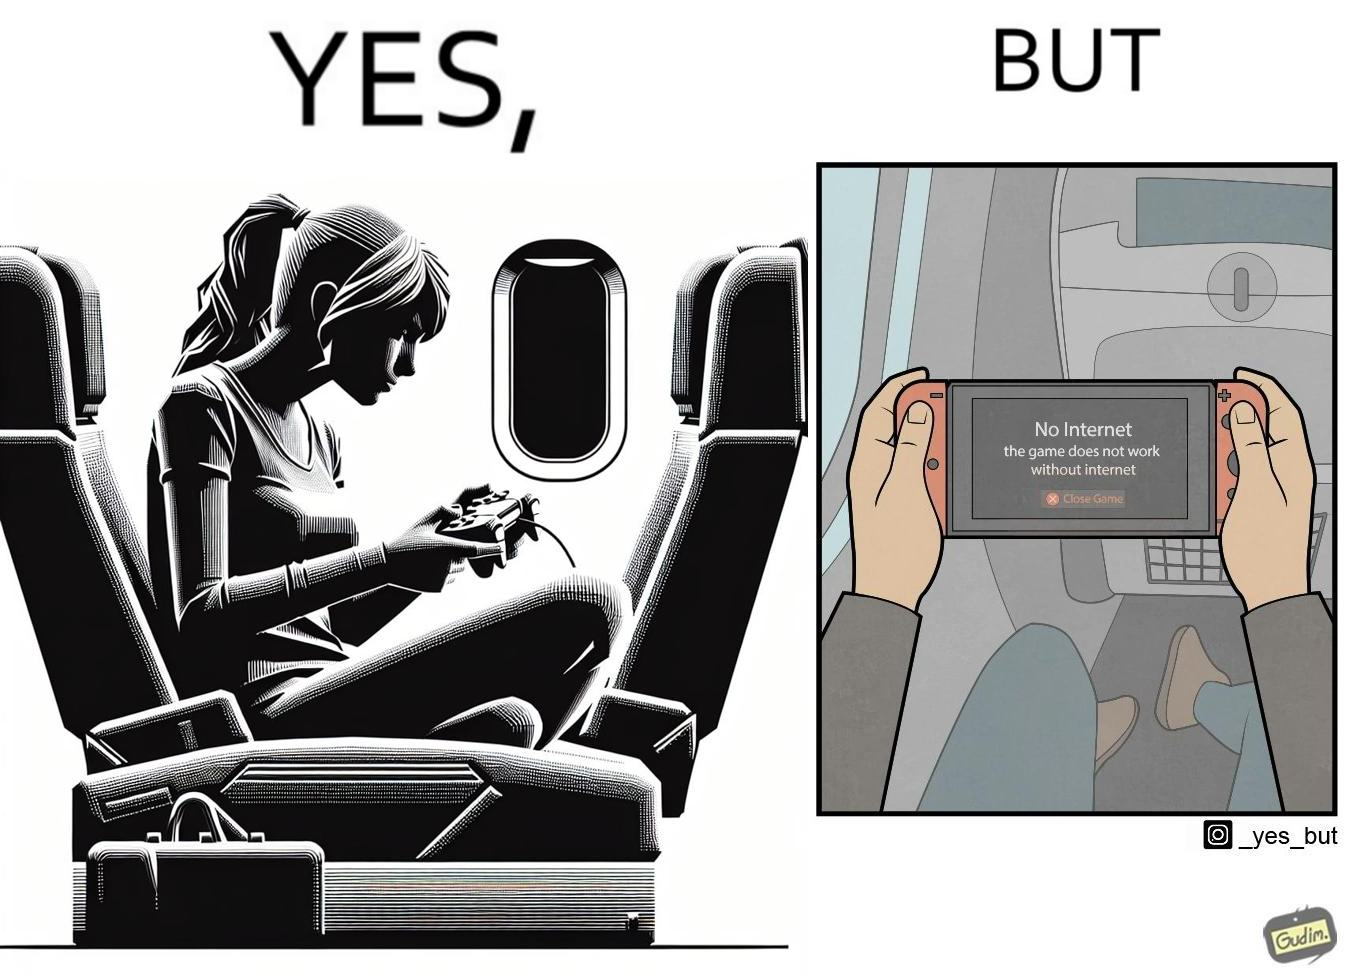Does this image contain satire or humor? Yes, this image is satirical. 